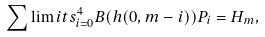Convert formula to latex. <formula><loc_0><loc_0><loc_500><loc_500>\sum \lim i t s _ { i = 0 } ^ { 4 } B ( h ( 0 , m - i ) ) P _ { i } = H _ { m } ,</formula> 